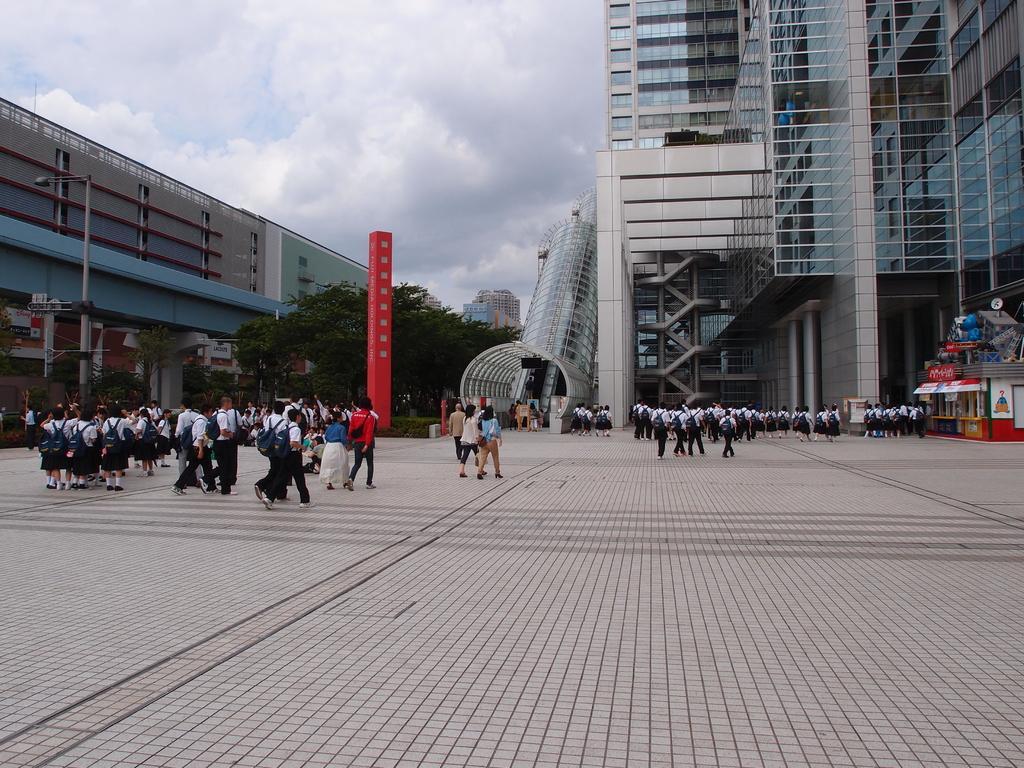Please provide a concise description of this image. In this image we can see people, trees, pole, plants, and buildings. In the background there is sky with clouds. 